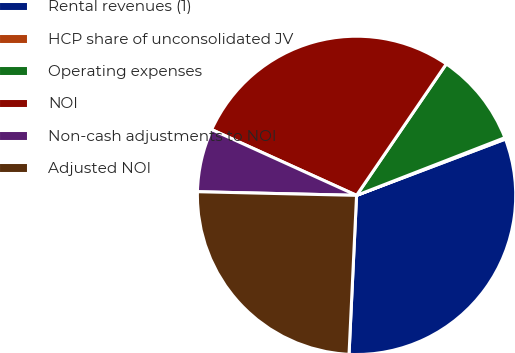Convert chart to OTSL. <chart><loc_0><loc_0><loc_500><loc_500><pie_chart><fcel>Rental revenues (1)<fcel>HCP share of unconsolidated JV<fcel>Operating expenses<fcel>NOI<fcel>Non-cash adjustments to NOI<fcel>Adjusted NOI<nl><fcel>31.51%<fcel>0.15%<fcel>9.56%<fcel>27.75%<fcel>6.42%<fcel>24.61%<nl></chart> 